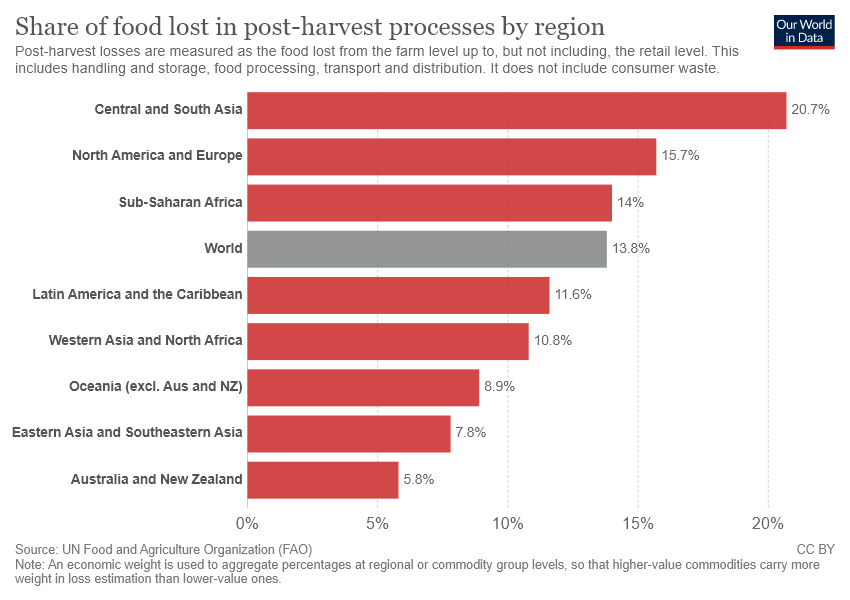Mention a couple of crucial points in this snapshot. It is estimated that approximately 0.138 of all food produced globally is lost during the post-harvest process. We aim to identify the regions with higher values than the world's average, and determine their relative contribution to the overall average by calculating their percentage of the total data. 